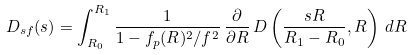<formula> <loc_0><loc_0><loc_500><loc_500>D _ { s f } ( s ) = \int _ { R _ { 0 } } ^ { R _ { 1 } } \frac { 1 } { 1 - f _ { p } ( R ) ^ { 2 } / f ^ { 2 } } \, \frac { \partial } { \partial R } \, D \left ( \frac { s R } { R _ { 1 } - R _ { 0 } } , R \right ) \, d R</formula> 